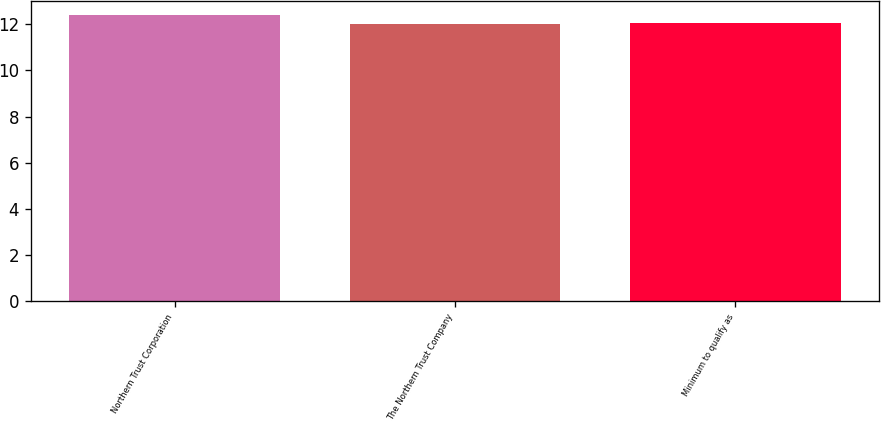Convert chart. <chart><loc_0><loc_0><loc_500><loc_500><bar_chart><fcel>Northern Trust Corporation<fcel>The Northern Trust Company<fcel>Minimum to qualify as<nl><fcel>12.4<fcel>12<fcel>12.04<nl></chart> 